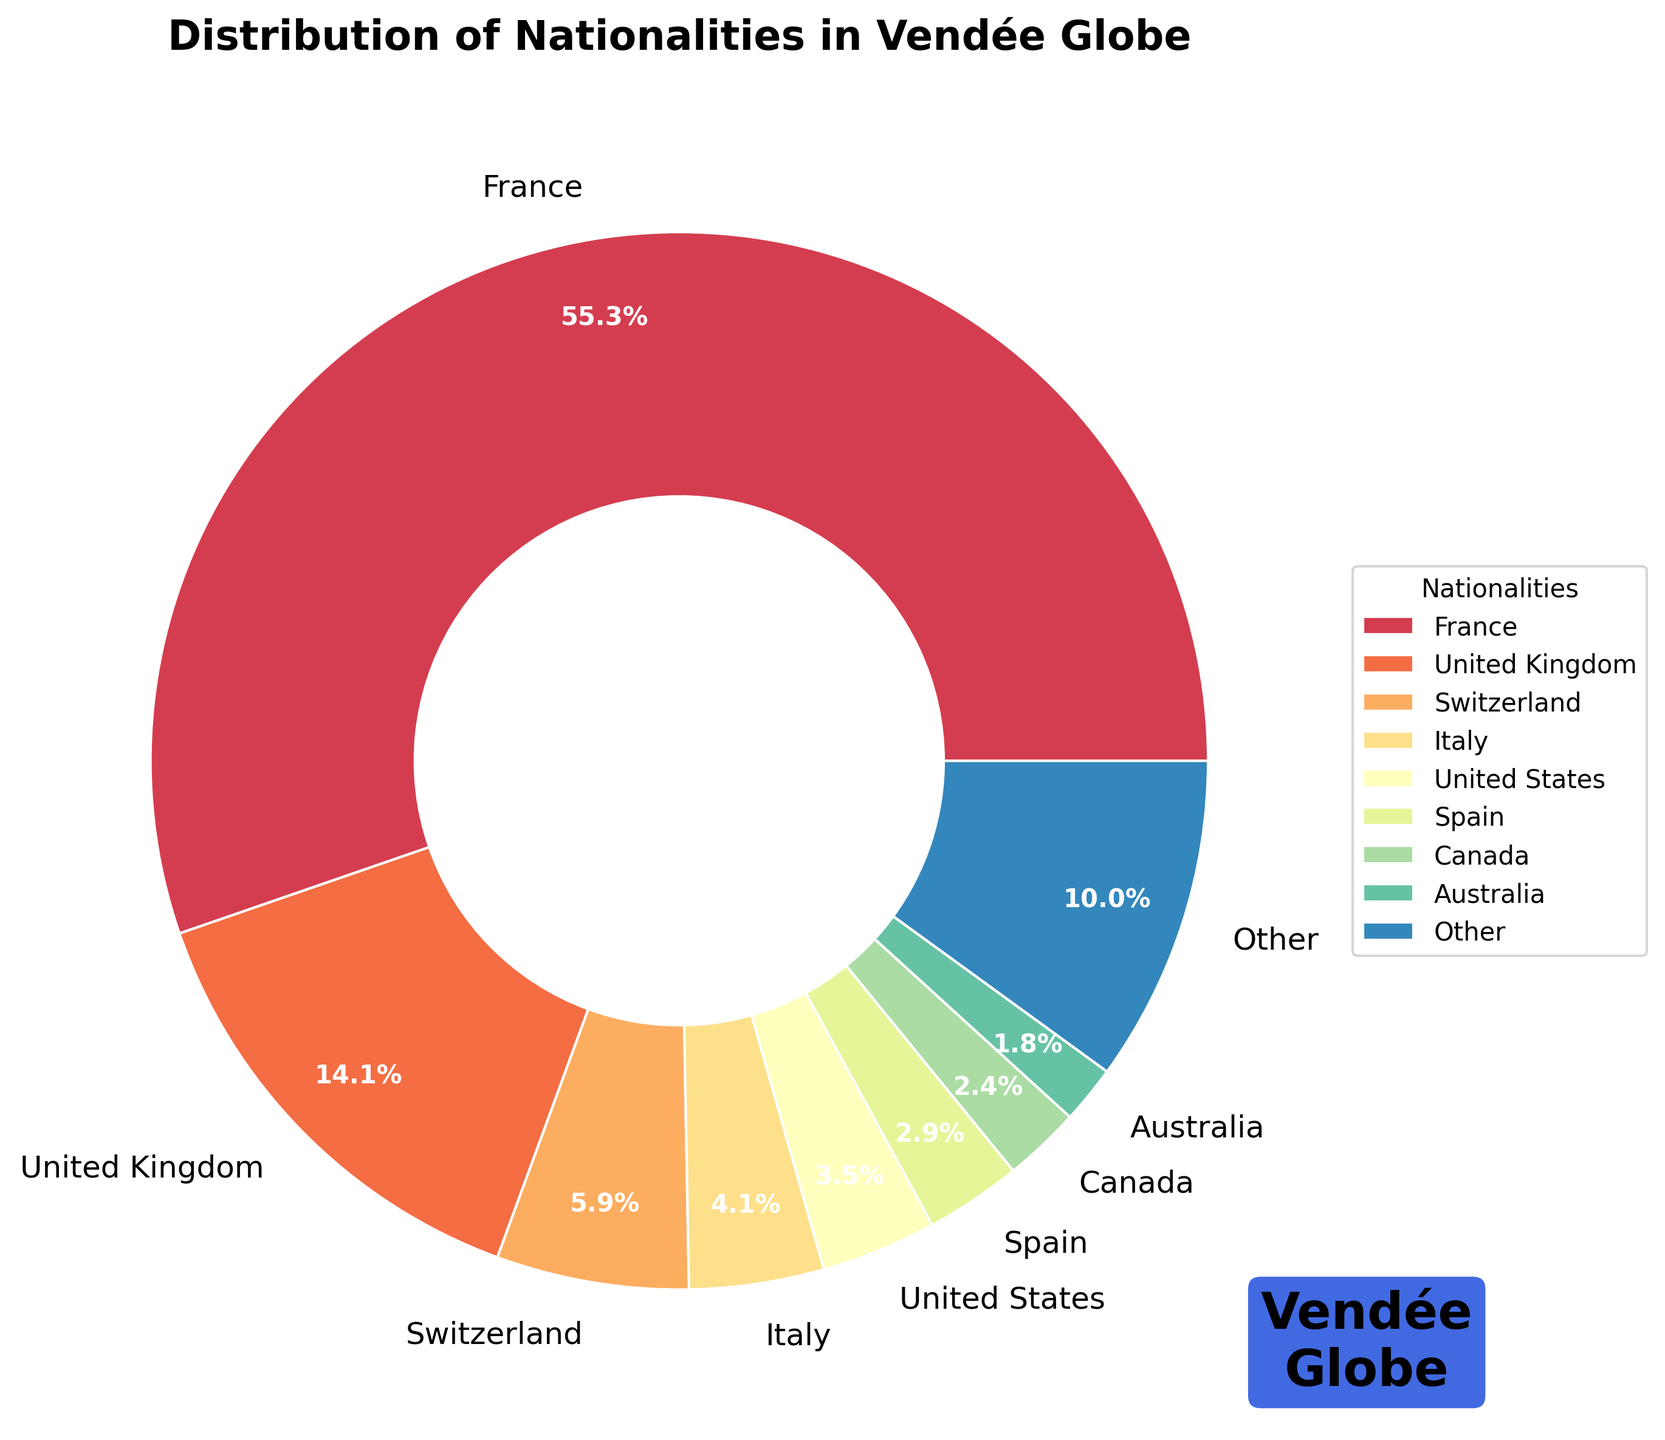What percentage of participants are from France? Look for the section of the pie chart labeled "France" and read the percentage directly from the figure.
Answer: 66.2% Which nationality has the second highest number of participants? Examine the pie chart to see which section is next in size after "France." The second-largest section will indicate the second highest number of participants.
Answer: United Kingdom How many nationalities have less than 3 participants? Identify the "Other" category, which aggregates the nationalities with fewer than 3 participants. Count the entries that add up to form this slice, seeing they include Hungary, Russia, New Zealand, Finland, Germany, Poland, Japan, Austria, South Africa, Netherlands, Belgium, and Bulgaria.
Answer: 12 What is the combined percentage of participants from Switzerland and Italy? Find the slices for Switzerland (7.0%) and Italy (4.9%), then add these percentages together.
Answer: 11.9% Is the number of participants from the United States greater than the number of participants from Spain? Visually compare the size of the slices labeled "United States" and "Spain." The United States has a larger slice.
Answer: Yes Which nationalities are specifically named in the legend of the chart? Read the legend that lists the nationalities with 3 or more participants, which are France, United Kingdom, Switzerland, Italy, United States, Spain, and Canada.
Answer: France, United Kingdom, Switzerland, Italy, United States, Spain, Canada What visual element highlights the Vendée Globe logo-like element in the chart? Look for the text and box style that stands out in the figure, indicating the Vendée Globe logo-like element.
Answer: A text box with "Vendée\nGlobe" in bold text within a rounded blue box with white edges Are there more participants from Canada or Australia? Compare the slices for Canada and Australia. The slice for Canada is slightly larger.
Answer: Canada What is the total percentage of participants not specifically labeled (grouped under "Other") in the chart? Identify the percentage labeled "Other" in the pie chart.
Answer: 8.5% How does the color palette affect the interpretability of the chart? Observe if the spectrum of colors in the figure from the color palette makes each slice distinguishable and enhances clarity. The use of distinct colors helps differentiate the nationalities.
Answer: It makes the chart more readable and visually distinct 